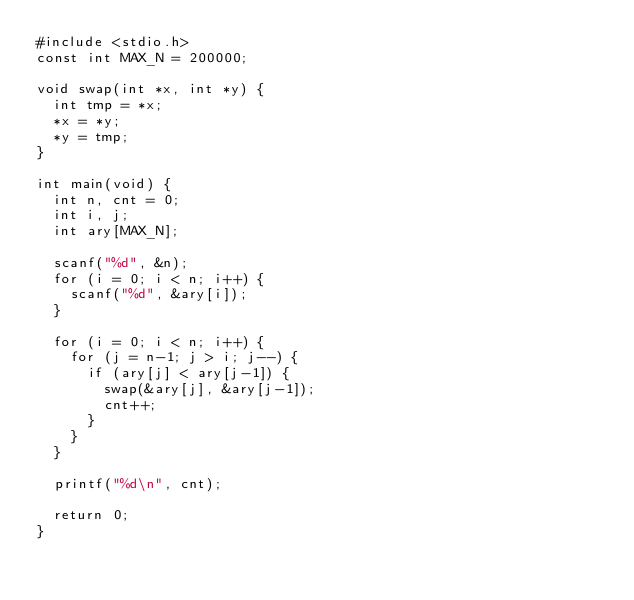Convert code to text. <code><loc_0><loc_0><loc_500><loc_500><_C_>#include <stdio.h>
const int MAX_N = 200000;

void swap(int *x, int *y) {
  int tmp = *x;
  *x = *y;
  *y = tmp;
}

int main(void) {
  int n, cnt = 0;
  int i, j;
  int ary[MAX_N];

  scanf("%d", &n);
  for (i = 0; i < n; i++) {
    scanf("%d", &ary[i]);
  }

  for (i = 0; i < n; i++) {
    for (j = n-1; j > i; j--) {
      if (ary[j] < ary[j-1]) {
        swap(&ary[j], &ary[j-1]);
        cnt++;
      }
    }
  }

  printf("%d\n", cnt);

  return 0;
}</code> 